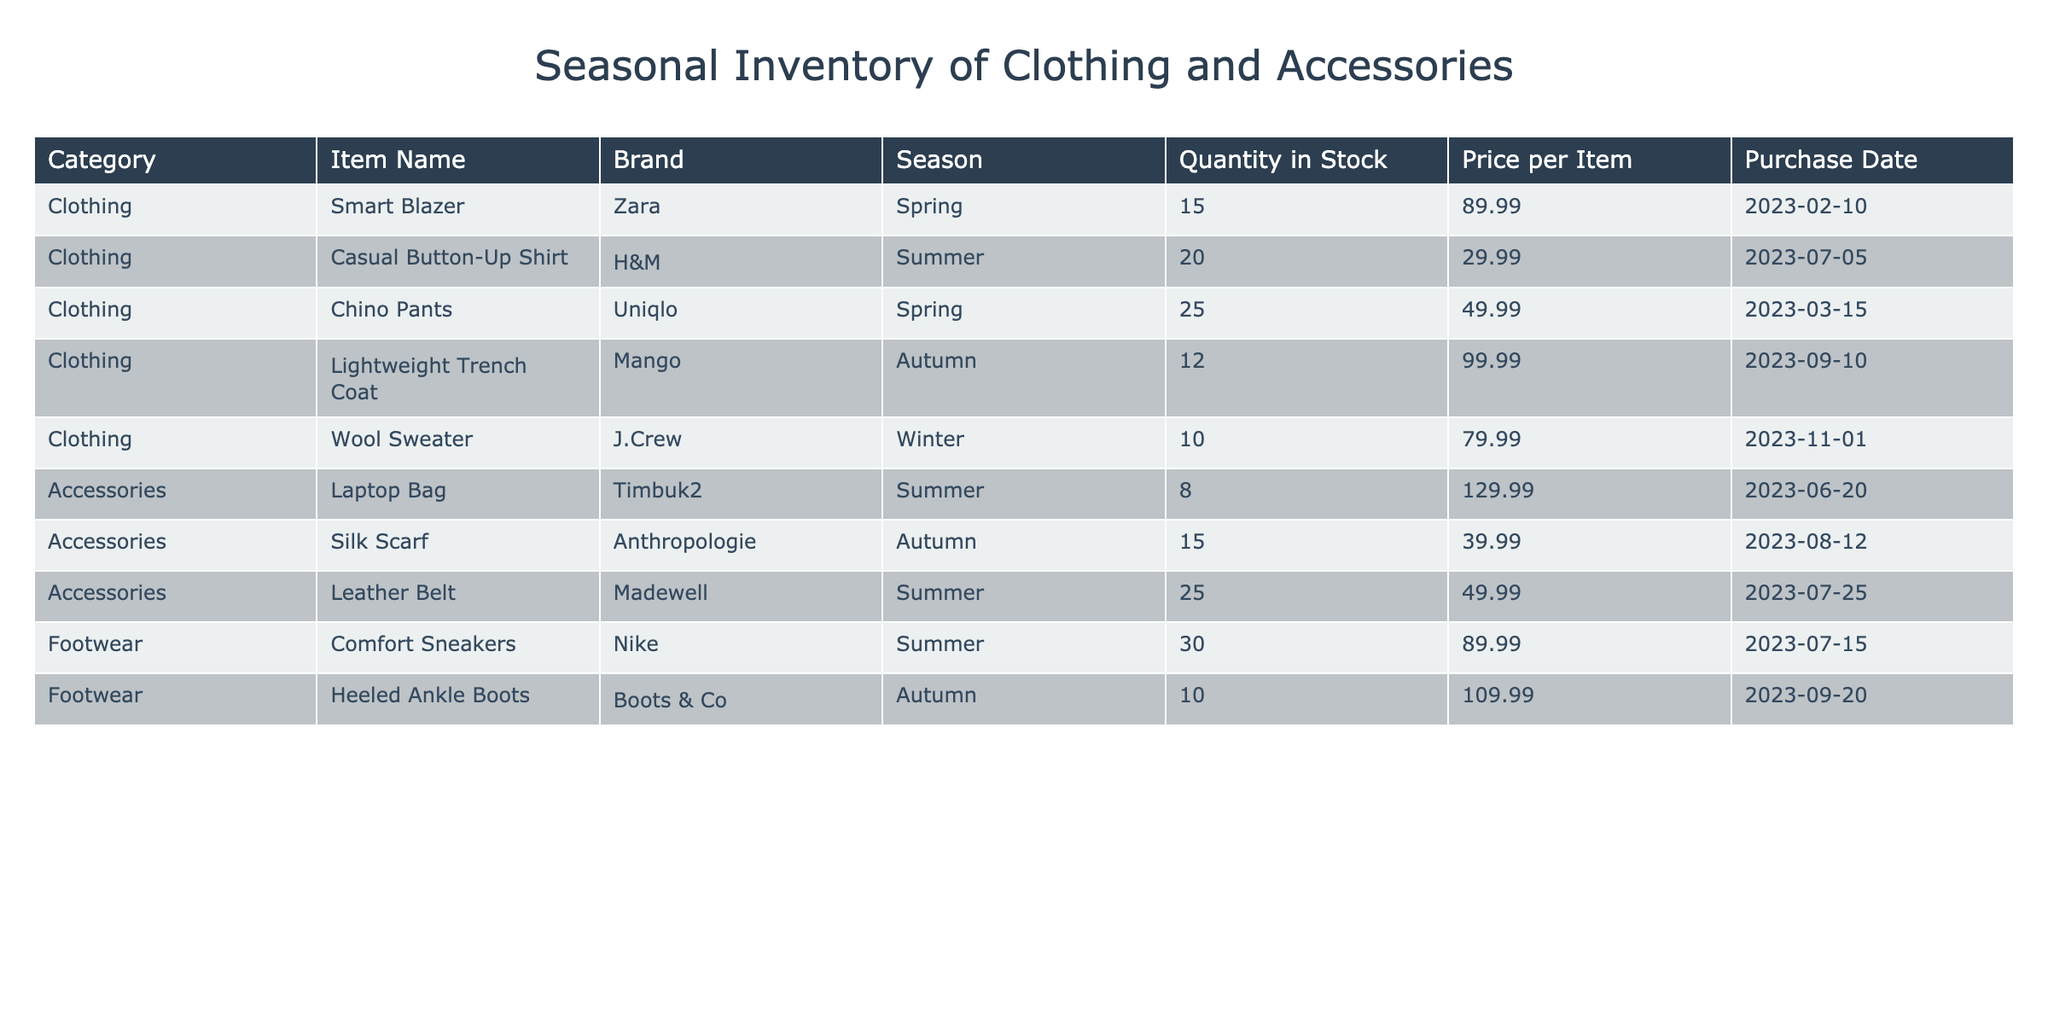What brand offers the most items in stock for summer? Looking at the summer season items, the brands are H&M, Timbuk2, Madewell, and Nike. For H&M, there are 20 Casual Button-Up Shirts; Timbuk2 has 8 Laptop Bags; Madewell has 25 Leather Belts; and Nike offers 30 Comfort Sneakers. Nike has the highest quantity with 30 items.
Answer: Nike How many total units of accessories do we have in stock? The inventory table lists accessories with the following quantities: 8 Laptop Bags, 15 Silk Scarves, and 25 Leather Belts. Adding these together gives 8 + 15 + 25 = 48 units total for accessories.
Answer: 48 Is there a winter item available in the inventory? The inventory table lists the Wool Sweater under the winter season. Since this item is present, the answer is yes.
Answer: Yes What is the average price of clothing items in the inventory? The clothing items and their prices are: Smart Blazer at 89.99, Casual Button-Up Shirt at 29.99, Chino Pants at 49.99, Lightweight Trench Coat at 99.99, and Wool Sweater at 79.99. Calculating the average: (89.99 + 29.99 + 49.99 + 99.99 + 79.99) / 5 = 67.99.
Answer: 67.99 How many more summer footwear items are available compared to autumn items? There are 30 Comfort Sneakers under summer and 10 Heeled Ankle Boots under autumn. The difference is 30 - 10 = 20 more summer footwear items than autumn ones.
Answer: 20 Which item has the highest price in the inventory? By examining the prices listed: Smart Blazer (89.99), Casual Button-Up Shirt (29.99), Chino Pants (49.99), Lightweight Trench Coat (99.99), Wool Sweater (79.99), Laptop Bag (129.99), Silk Scarf (39.99), Leather Belt (49.99), Comfort Sneakers (89.99), and Heeled Ankle Boots (109.99). The Laptop Bag at 129.99 is the highest priced item.
Answer: Laptop Bag What is the total stock quantity for spring clothing? The spring clothing items are the Smart Blazer with 15 and Chino Pants with 25 in stock. Adding these together gives 15 + 25 = 40 for total spring clothing stock.
Answer: 40 Are there any items from Mango in stock? The inventory shows an item from Mango, which is the Lightweight Trench Coat for Autumn. Therefore, the answer is yes.
Answer: Yes 